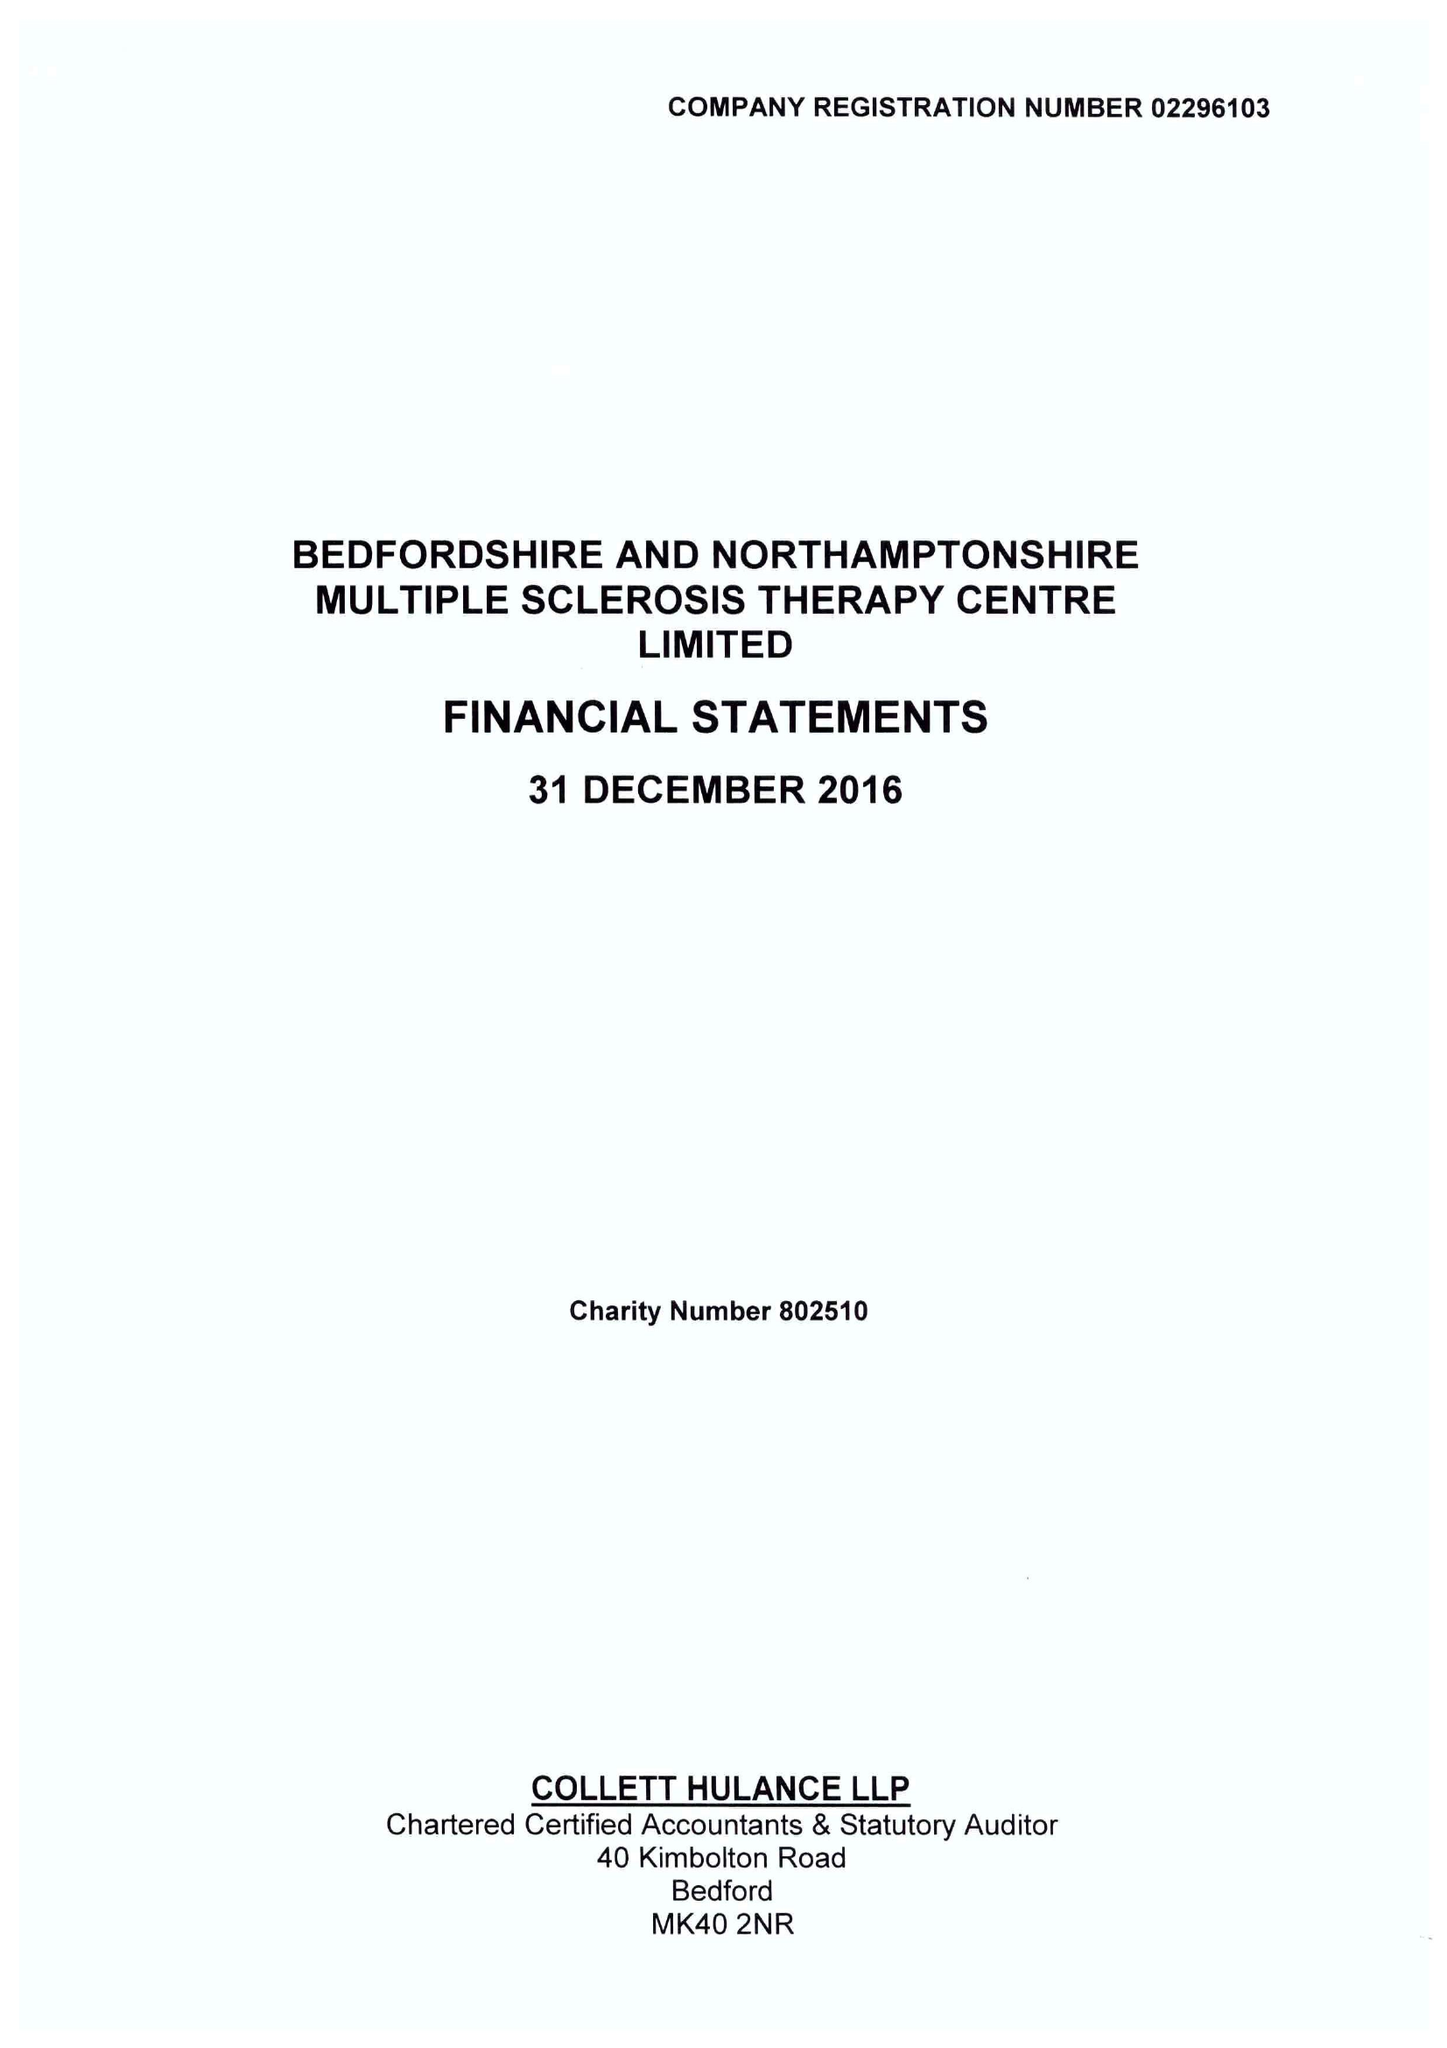What is the value for the charity_name?
Answer the question using a single word or phrase. Bedfordshire and Northamptonshire Multiple Sclerosis Therapy Centre Ltd. 